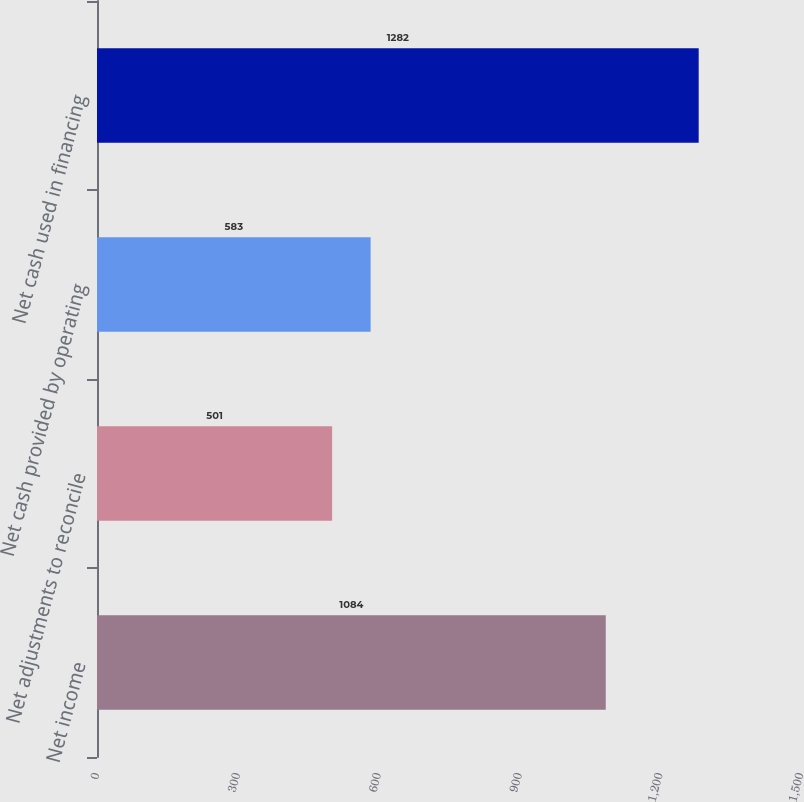<chart> <loc_0><loc_0><loc_500><loc_500><bar_chart><fcel>Net income<fcel>Net adjustments to reconcile<fcel>Net cash provided by operating<fcel>Net cash used in financing<nl><fcel>1084<fcel>501<fcel>583<fcel>1282<nl></chart> 